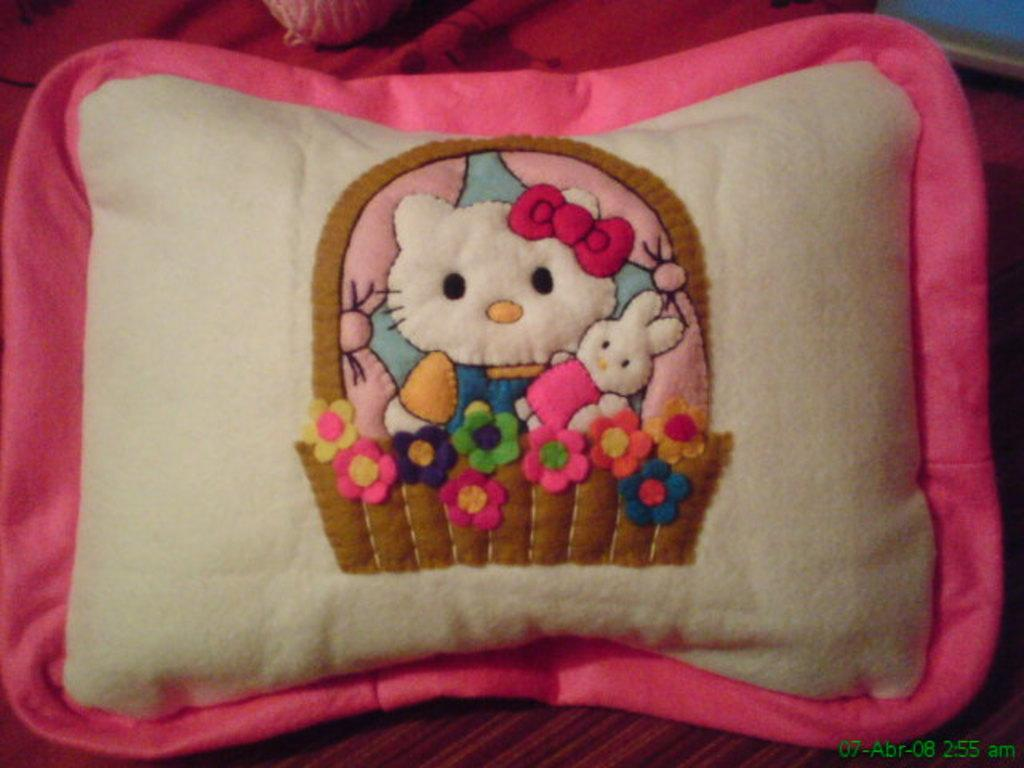What object is present in the image? There is a pillow in the image. What colors can be seen on the pillow? The pillow is white and pink in color. What else is on the pillow? There are two dolls on the pillow. Are there any other decorative elements on the pillow? Yes, there are multicolored flowers on the pillow. What type of work is being done by the dolls in the image? There is no indication of work being done by the dolls in the image; they are simply placed on the pillow. 